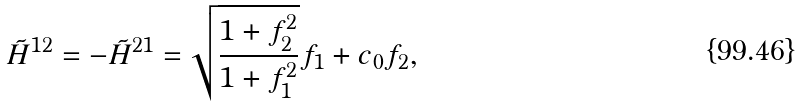Convert formula to latex. <formula><loc_0><loc_0><loc_500><loc_500>\tilde { H } ^ { 1 2 } = - \tilde { H } ^ { 2 1 } = \sqrt { \frac { 1 + f _ { 2 } ^ { 2 } } { 1 + f _ { 1 } ^ { 2 } } } f _ { 1 } + c _ { 0 } f _ { 2 } ,</formula> 